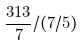Convert formula to latex. <formula><loc_0><loc_0><loc_500><loc_500>\frac { 3 1 3 } { 7 } / ( 7 / 5 )</formula> 